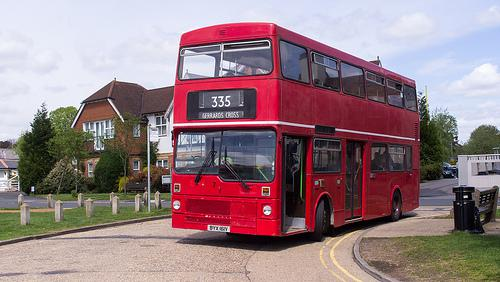Question: what will get off the bus?
Choices:
A. Wheelchairs.
B. People.
C. Pets.
D. Belongings of people.
Answer with the letter. Answer: B Question: what is on the street?
Choices:
A. Car.
B. Motorcycles.
C. Bus.
D. Bicycles.
Answer with the letter. Answer: C Question: who is on the bus?
Choices:
A. People.
B. Elderly.
C. Handicapped.
D. Students.
Answer with the letter. Answer: A 